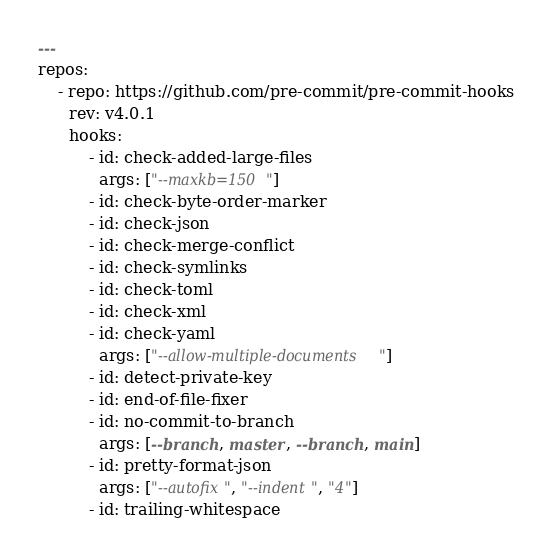Convert code to text. <code><loc_0><loc_0><loc_500><loc_500><_YAML_>---
repos:
    - repo: https://github.com/pre-commit/pre-commit-hooks
      rev: v4.0.1
      hooks:
          - id: check-added-large-files
            args: ["--maxkb=150"]
          - id: check-byte-order-marker
          - id: check-json
          - id: check-merge-conflict
          - id: check-symlinks
          - id: check-toml
          - id: check-xml
          - id: check-yaml
            args: ["--allow-multiple-documents"]
          - id: detect-private-key
          - id: end-of-file-fixer
          - id: no-commit-to-branch
            args: [--branch, master, --branch, main]
          - id: pretty-format-json
            args: ["--autofix", "--indent", "4"]
          - id: trailing-whitespace
</code> 